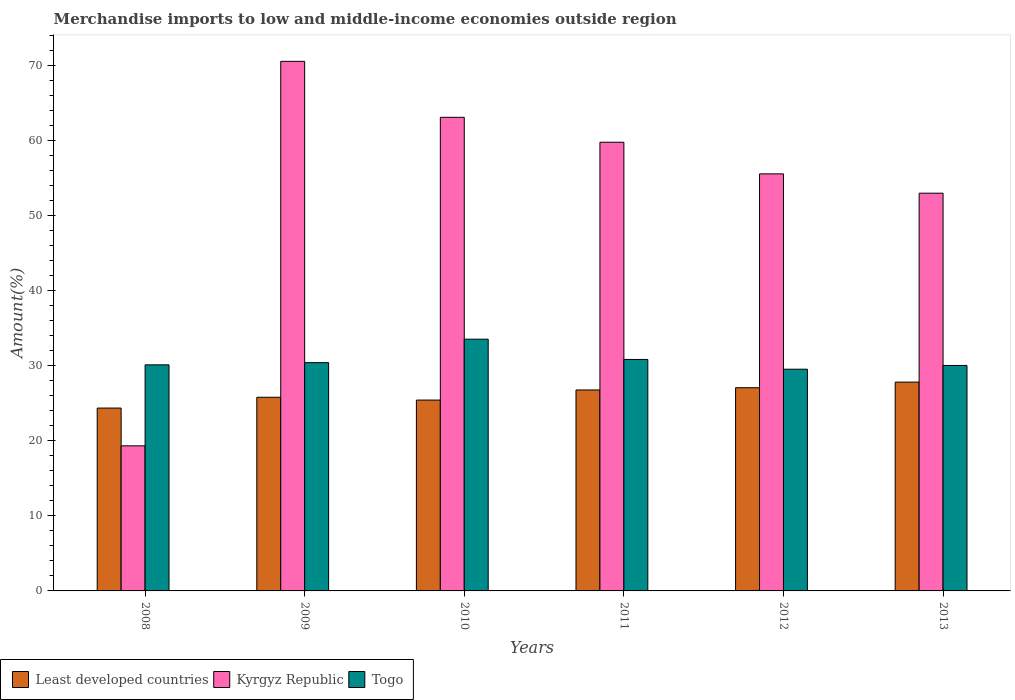How many different coloured bars are there?
Provide a succinct answer. 3. How many bars are there on the 5th tick from the right?
Your response must be concise. 3. What is the label of the 2nd group of bars from the left?
Ensure brevity in your answer.  2009. What is the percentage of amount earned from merchandise imports in Togo in 2013?
Make the answer very short. 30.05. Across all years, what is the maximum percentage of amount earned from merchandise imports in Kyrgyz Republic?
Give a very brief answer. 70.57. Across all years, what is the minimum percentage of amount earned from merchandise imports in Togo?
Your response must be concise. 29.55. In which year was the percentage of amount earned from merchandise imports in Kyrgyz Republic maximum?
Make the answer very short. 2009. What is the total percentage of amount earned from merchandise imports in Kyrgyz Republic in the graph?
Offer a very short reply. 321.39. What is the difference between the percentage of amount earned from merchandise imports in Least developed countries in 2009 and that in 2010?
Ensure brevity in your answer.  0.38. What is the difference between the percentage of amount earned from merchandise imports in Togo in 2011 and the percentage of amount earned from merchandise imports in Least developed countries in 2008?
Your answer should be very brief. 6.48. What is the average percentage of amount earned from merchandise imports in Kyrgyz Republic per year?
Your answer should be compact. 53.57. In the year 2013, what is the difference between the percentage of amount earned from merchandise imports in Kyrgyz Republic and percentage of amount earned from merchandise imports in Least developed countries?
Give a very brief answer. 25.18. In how many years, is the percentage of amount earned from merchandise imports in Togo greater than 46 %?
Your response must be concise. 0. What is the ratio of the percentage of amount earned from merchandise imports in Kyrgyz Republic in 2010 to that in 2012?
Your answer should be very brief. 1.14. Is the percentage of amount earned from merchandise imports in Least developed countries in 2009 less than that in 2013?
Keep it short and to the point. Yes. Is the difference between the percentage of amount earned from merchandise imports in Kyrgyz Republic in 2008 and 2011 greater than the difference between the percentage of amount earned from merchandise imports in Least developed countries in 2008 and 2011?
Your response must be concise. No. What is the difference between the highest and the second highest percentage of amount earned from merchandise imports in Least developed countries?
Ensure brevity in your answer.  0.75. What is the difference between the highest and the lowest percentage of amount earned from merchandise imports in Least developed countries?
Ensure brevity in your answer.  3.46. What does the 2nd bar from the left in 2010 represents?
Ensure brevity in your answer.  Kyrgyz Republic. What does the 3rd bar from the right in 2013 represents?
Give a very brief answer. Least developed countries. How many bars are there?
Provide a succinct answer. 18. Does the graph contain grids?
Offer a very short reply. No. What is the title of the graph?
Your answer should be compact. Merchandise imports to low and middle-income economies outside region. Does "San Marino" appear as one of the legend labels in the graph?
Provide a succinct answer. No. What is the label or title of the Y-axis?
Provide a succinct answer. Amount(%). What is the Amount(%) of Least developed countries in 2008?
Make the answer very short. 24.37. What is the Amount(%) in Kyrgyz Republic in 2008?
Ensure brevity in your answer.  19.33. What is the Amount(%) of Togo in 2008?
Offer a terse response. 30.13. What is the Amount(%) in Least developed countries in 2009?
Provide a short and direct response. 25.81. What is the Amount(%) in Kyrgyz Republic in 2009?
Keep it short and to the point. 70.57. What is the Amount(%) in Togo in 2009?
Your answer should be very brief. 30.42. What is the Amount(%) of Least developed countries in 2010?
Ensure brevity in your answer.  25.43. What is the Amount(%) in Kyrgyz Republic in 2010?
Provide a succinct answer. 63.11. What is the Amount(%) of Togo in 2010?
Your answer should be very brief. 33.55. What is the Amount(%) of Least developed countries in 2011?
Give a very brief answer. 26.78. What is the Amount(%) of Kyrgyz Republic in 2011?
Provide a succinct answer. 59.79. What is the Amount(%) in Togo in 2011?
Your answer should be compact. 30.85. What is the Amount(%) in Least developed countries in 2012?
Provide a short and direct response. 27.08. What is the Amount(%) in Kyrgyz Republic in 2012?
Keep it short and to the point. 55.58. What is the Amount(%) of Togo in 2012?
Your response must be concise. 29.55. What is the Amount(%) in Least developed countries in 2013?
Your answer should be very brief. 27.83. What is the Amount(%) in Kyrgyz Republic in 2013?
Your answer should be very brief. 53. What is the Amount(%) of Togo in 2013?
Offer a terse response. 30.05. Across all years, what is the maximum Amount(%) of Least developed countries?
Provide a short and direct response. 27.83. Across all years, what is the maximum Amount(%) in Kyrgyz Republic?
Provide a short and direct response. 70.57. Across all years, what is the maximum Amount(%) in Togo?
Your answer should be compact. 33.55. Across all years, what is the minimum Amount(%) of Least developed countries?
Offer a terse response. 24.37. Across all years, what is the minimum Amount(%) of Kyrgyz Republic?
Your answer should be very brief. 19.33. Across all years, what is the minimum Amount(%) in Togo?
Give a very brief answer. 29.55. What is the total Amount(%) of Least developed countries in the graph?
Provide a succinct answer. 157.29. What is the total Amount(%) in Kyrgyz Republic in the graph?
Your response must be concise. 321.39. What is the total Amount(%) in Togo in the graph?
Make the answer very short. 184.53. What is the difference between the Amount(%) of Least developed countries in 2008 and that in 2009?
Offer a very short reply. -1.44. What is the difference between the Amount(%) of Kyrgyz Republic in 2008 and that in 2009?
Offer a terse response. -51.24. What is the difference between the Amount(%) in Togo in 2008 and that in 2009?
Offer a terse response. -0.3. What is the difference between the Amount(%) of Least developed countries in 2008 and that in 2010?
Offer a terse response. -1.07. What is the difference between the Amount(%) of Kyrgyz Republic in 2008 and that in 2010?
Offer a terse response. -43.78. What is the difference between the Amount(%) in Togo in 2008 and that in 2010?
Your response must be concise. -3.42. What is the difference between the Amount(%) of Least developed countries in 2008 and that in 2011?
Provide a succinct answer. -2.41. What is the difference between the Amount(%) of Kyrgyz Republic in 2008 and that in 2011?
Provide a short and direct response. -40.46. What is the difference between the Amount(%) in Togo in 2008 and that in 2011?
Your answer should be very brief. -0.72. What is the difference between the Amount(%) in Least developed countries in 2008 and that in 2012?
Your response must be concise. -2.71. What is the difference between the Amount(%) in Kyrgyz Republic in 2008 and that in 2012?
Your response must be concise. -36.24. What is the difference between the Amount(%) of Togo in 2008 and that in 2012?
Keep it short and to the point. 0.58. What is the difference between the Amount(%) of Least developed countries in 2008 and that in 2013?
Make the answer very short. -3.46. What is the difference between the Amount(%) in Kyrgyz Republic in 2008 and that in 2013?
Give a very brief answer. -33.67. What is the difference between the Amount(%) of Togo in 2008 and that in 2013?
Ensure brevity in your answer.  0.08. What is the difference between the Amount(%) of Least developed countries in 2009 and that in 2010?
Offer a very short reply. 0.38. What is the difference between the Amount(%) in Kyrgyz Republic in 2009 and that in 2010?
Offer a terse response. 7.46. What is the difference between the Amount(%) in Togo in 2009 and that in 2010?
Offer a very short reply. -3.13. What is the difference between the Amount(%) of Least developed countries in 2009 and that in 2011?
Make the answer very short. -0.97. What is the difference between the Amount(%) in Kyrgyz Republic in 2009 and that in 2011?
Give a very brief answer. 10.78. What is the difference between the Amount(%) in Togo in 2009 and that in 2011?
Keep it short and to the point. -0.42. What is the difference between the Amount(%) in Least developed countries in 2009 and that in 2012?
Give a very brief answer. -1.27. What is the difference between the Amount(%) in Kyrgyz Republic in 2009 and that in 2012?
Offer a terse response. 14.99. What is the difference between the Amount(%) in Togo in 2009 and that in 2012?
Give a very brief answer. 0.88. What is the difference between the Amount(%) of Least developed countries in 2009 and that in 2013?
Give a very brief answer. -2.02. What is the difference between the Amount(%) of Kyrgyz Republic in 2009 and that in 2013?
Your response must be concise. 17.57. What is the difference between the Amount(%) in Togo in 2009 and that in 2013?
Your answer should be very brief. 0.37. What is the difference between the Amount(%) of Least developed countries in 2010 and that in 2011?
Make the answer very short. -1.35. What is the difference between the Amount(%) of Kyrgyz Republic in 2010 and that in 2011?
Your answer should be compact. 3.32. What is the difference between the Amount(%) of Togo in 2010 and that in 2011?
Make the answer very short. 2.7. What is the difference between the Amount(%) in Least developed countries in 2010 and that in 2012?
Make the answer very short. -1.65. What is the difference between the Amount(%) in Kyrgyz Republic in 2010 and that in 2012?
Provide a short and direct response. 7.54. What is the difference between the Amount(%) of Togo in 2010 and that in 2012?
Your answer should be very brief. 4. What is the difference between the Amount(%) in Least developed countries in 2010 and that in 2013?
Make the answer very short. -2.39. What is the difference between the Amount(%) in Kyrgyz Republic in 2010 and that in 2013?
Provide a succinct answer. 10.11. What is the difference between the Amount(%) of Togo in 2010 and that in 2013?
Offer a terse response. 3.5. What is the difference between the Amount(%) in Least developed countries in 2011 and that in 2012?
Your answer should be compact. -0.3. What is the difference between the Amount(%) of Kyrgyz Republic in 2011 and that in 2012?
Ensure brevity in your answer.  4.21. What is the difference between the Amount(%) in Least developed countries in 2011 and that in 2013?
Your answer should be very brief. -1.05. What is the difference between the Amount(%) in Kyrgyz Republic in 2011 and that in 2013?
Provide a short and direct response. 6.79. What is the difference between the Amount(%) of Togo in 2011 and that in 2013?
Provide a short and direct response. 0.8. What is the difference between the Amount(%) of Least developed countries in 2012 and that in 2013?
Provide a succinct answer. -0.75. What is the difference between the Amount(%) of Kyrgyz Republic in 2012 and that in 2013?
Offer a terse response. 2.58. What is the difference between the Amount(%) in Togo in 2012 and that in 2013?
Ensure brevity in your answer.  -0.5. What is the difference between the Amount(%) of Least developed countries in 2008 and the Amount(%) of Kyrgyz Republic in 2009?
Offer a terse response. -46.2. What is the difference between the Amount(%) of Least developed countries in 2008 and the Amount(%) of Togo in 2009?
Offer a very short reply. -6.05. What is the difference between the Amount(%) of Kyrgyz Republic in 2008 and the Amount(%) of Togo in 2009?
Give a very brief answer. -11.09. What is the difference between the Amount(%) of Least developed countries in 2008 and the Amount(%) of Kyrgyz Republic in 2010?
Give a very brief answer. -38.75. What is the difference between the Amount(%) of Least developed countries in 2008 and the Amount(%) of Togo in 2010?
Your answer should be compact. -9.18. What is the difference between the Amount(%) of Kyrgyz Republic in 2008 and the Amount(%) of Togo in 2010?
Your answer should be very brief. -14.21. What is the difference between the Amount(%) in Least developed countries in 2008 and the Amount(%) in Kyrgyz Republic in 2011?
Offer a very short reply. -35.43. What is the difference between the Amount(%) in Least developed countries in 2008 and the Amount(%) in Togo in 2011?
Make the answer very short. -6.48. What is the difference between the Amount(%) of Kyrgyz Republic in 2008 and the Amount(%) of Togo in 2011?
Keep it short and to the point. -11.51. What is the difference between the Amount(%) of Least developed countries in 2008 and the Amount(%) of Kyrgyz Republic in 2012?
Give a very brief answer. -31.21. What is the difference between the Amount(%) in Least developed countries in 2008 and the Amount(%) in Togo in 2012?
Your answer should be compact. -5.18. What is the difference between the Amount(%) of Kyrgyz Republic in 2008 and the Amount(%) of Togo in 2012?
Provide a succinct answer. -10.21. What is the difference between the Amount(%) in Least developed countries in 2008 and the Amount(%) in Kyrgyz Republic in 2013?
Make the answer very short. -28.64. What is the difference between the Amount(%) in Least developed countries in 2008 and the Amount(%) in Togo in 2013?
Provide a succinct answer. -5.68. What is the difference between the Amount(%) of Kyrgyz Republic in 2008 and the Amount(%) of Togo in 2013?
Your answer should be very brief. -10.71. What is the difference between the Amount(%) in Least developed countries in 2009 and the Amount(%) in Kyrgyz Republic in 2010?
Give a very brief answer. -37.31. What is the difference between the Amount(%) in Least developed countries in 2009 and the Amount(%) in Togo in 2010?
Keep it short and to the point. -7.74. What is the difference between the Amount(%) of Kyrgyz Republic in 2009 and the Amount(%) of Togo in 2010?
Ensure brevity in your answer.  37.02. What is the difference between the Amount(%) in Least developed countries in 2009 and the Amount(%) in Kyrgyz Republic in 2011?
Give a very brief answer. -33.98. What is the difference between the Amount(%) of Least developed countries in 2009 and the Amount(%) of Togo in 2011?
Keep it short and to the point. -5.04. What is the difference between the Amount(%) in Kyrgyz Republic in 2009 and the Amount(%) in Togo in 2011?
Keep it short and to the point. 39.73. What is the difference between the Amount(%) of Least developed countries in 2009 and the Amount(%) of Kyrgyz Republic in 2012?
Ensure brevity in your answer.  -29.77. What is the difference between the Amount(%) of Least developed countries in 2009 and the Amount(%) of Togo in 2012?
Make the answer very short. -3.74. What is the difference between the Amount(%) of Kyrgyz Republic in 2009 and the Amount(%) of Togo in 2012?
Offer a very short reply. 41.03. What is the difference between the Amount(%) of Least developed countries in 2009 and the Amount(%) of Kyrgyz Republic in 2013?
Provide a short and direct response. -27.2. What is the difference between the Amount(%) in Least developed countries in 2009 and the Amount(%) in Togo in 2013?
Provide a succinct answer. -4.24. What is the difference between the Amount(%) of Kyrgyz Republic in 2009 and the Amount(%) of Togo in 2013?
Your answer should be compact. 40.52. What is the difference between the Amount(%) in Least developed countries in 2010 and the Amount(%) in Kyrgyz Republic in 2011?
Provide a short and direct response. -34.36. What is the difference between the Amount(%) in Least developed countries in 2010 and the Amount(%) in Togo in 2011?
Give a very brief answer. -5.41. What is the difference between the Amount(%) of Kyrgyz Republic in 2010 and the Amount(%) of Togo in 2011?
Make the answer very short. 32.27. What is the difference between the Amount(%) of Least developed countries in 2010 and the Amount(%) of Kyrgyz Republic in 2012?
Your answer should be compact. -30.15. What is the difference between the Amount(%) in Least developed countries in 2010 and the Amount(%) in Togo in 2012?
Your answer should be compact. -4.11. What is the difference between the Amount(%) in Kyrgyz Republic in 2010 and the Amount(%) in Togo in 2012?
Your answer should be very brief. 33.57. What is the difference between the Amount(%) of Least developed countries in 2010 and the Amount(%) of Kyrgyz Republic in 2013?
Provide a short and direct response. -27.57. What is the difference between the Amount(%) of Least developed countries in 2010 and the Amount(%) of Togo in 2013?
Give a very brief answer. -4.62. What is the difference between the Amount(%) in Kyrgyz Republic in 2010 and the Amount(%) in Togo in 2013?
Offer a very short reply. 33.07. What is the difference between the Amount(%) in Least developed countries in 2011 and the Amount(%) in Kyrgyz Republic in 2012?
Ensure brevity in your answer.  -28.8. What is the difference between the Amount(%) in Least developed countries in 2011 and the Amount(%) in Togo in 2012?
Provide a succinct answer. -2.77. What is the difference between the Amount(%) of Kyrgyz Republic in 2011 and the Amount(%) of Togo in 2012?
Make the answer very short. 30.25. What is the difference between the Amount(%) of Least developed countries in 2011 and the Amount(%) of Kyrgyz Republic in 2013?
Give a very brief answer. -26.22. What is the difference between the Amount(%) in Least developed countries in 2011 and the Amount(%) in Togo in 2013?
Your response must be concise. -3.27. What is the difference between the Amount(%) of Kyrgyz Republic in 2011 and the Amount(%) of Togo in 2013?
Ensure brevity in your answer.  29.75. What is the difference between the Amount(%) in Least developed countries in 2012 and the Amount(%) in Kyrgyz Republic in 2013?
Provide a short and direct response. -25.92. What is the difference between the Amount(%) in Least developed countries in 2012 and the Amount(%) in Togo in 2013?
Make the answer very short. -2.97. What is the difference between the Amount(%) in Kyrgyz Republic in 2012 and the Amount(%) in Togo in 2013?
Make the answer very short. 25.53. What is the average Amount(%) of Least developed countries per year?
Your answer should be very brief. 26.22. What is the average Amount(%) in Kyrgyz Republic per year?
Ensure brevity in your answer.  53.57. What is the average Amount(%) in Togo per year?
Give a very brief answer. 30.76. In the year 2008, what is the difference between the Amount(%) of Least developed countries and Amount(%) of Kyrgyz Republic?
Offer a terse response. 5.03. In the year 2008, what is the difference between the Amount(%) of Least developed countries and Amount(%) of Togo?
Offer a terse response. -5.76. In the year 2008, what is the difference between the Amount(%) in Kyrgyz Republic and Amount(%) in Togo?
Offer a very short reply. -10.79. In the year 2009, what is the difference between the Amount(%) of Least developed countries and Amount(%) of Kyrgyz Republic?
Provide a succinct answer. -44.76. In the year 2009, what is the difference between the Amount(%) in Least developed countries and Amount(%) in Togo?
Your answer should be very brief. -4.61. In the year 2009, what is the difference between the Amount(%) of Kyrgyz Republic and Amount(%) of Togo?
Provide a short and direct response. 40.15. In the year 2010, what is the difference between the Amount(%) in Least developed countries and Amount(%) in Kyrgyz Republic?
Your response must be concise. -37.68. In the year 2010, what is the difference between the Amount(%) in Least developed countries and Amount(%) in Togo?
Your answer should be compact. -8.12. In the year 2010, what is the difference between the Amount(%) of Kyrgyz Republic and Amount(%) of Togo?
Offer a terse response. 29.56. In the year 2011, what is the difference between the Amount(%) of Least developed countries and Amount(%) of Kyrgyz Republic?
Offer a terse response. -33.01. In the year 2011, what is the difference between the Amount(%) in Least developed countries and Amount(%) in Togo?
Make the answer very short. -4.07. In the year 2011, what is the difference between the Amount(%) in Kyrgyz Republic and Amount(%) in Togo?
Your answer should be compact. 28.95. In the year 2012, what is the difference between the Amount(%) of Least developed countries and Amount(%) of Kyrgyz Republic?
Make the answer very short. -28.5. In the year 2012, what is the difference between the Amount(%) in Least developed countries and Amount(%) in Togo?
Provide a succinct answer. -2.47. In the year 2012, what is the difference between the Amount(%) in Kyrgyz Republic and Amount(%) in Togo?
Your answer should be compact. 26.03. In the year 2013, what is the difference between the Amount(%) in Least developed countries and Amount(%) in Kyrgyz Republic?
Keep it short and to the point. -25.18. In the year 2013, what is the difference between the Amount(%) in Least developed countries and Amount(%) in Togo?
Offer a terse response. -2.22. In the year 2013, what is the difference between the Amount(%) of Kyrgyz Republic and Amount(%) of Togo?
Make the answer very short. 22.96. What is the ratio of the Amount(%) of Least developed countries in 2008 to that in 2009?
Provide a short and direct response. 0.94. What is the ratio of the Amount(%) of Kyrgyz Republic in 2008 to that in 2009?
Provide a short and direct response. 0.27. What is the ratio of the Amount(%) in Togo in 2008 to that in 2009?
Ensure brevity in your answer.  0.99. What is the ratio of the Amount(%) in Least developed countries in 2008 to that in 2010?
Offer a terse response. 0.96. What is the ratio of the Amount(%) of Kyrgyz Republic in 2008 to that in 2010?
Keep it short and to the point. 0.31. What is the ratio of the Amount(%) in Togo in 2008 to that in 2010?
Keep it short and to the point. 0.9. What is the ratio of the Amount(%) in Least developed countries in 2008 to that in 2011?
Make the answer very short. 0.91. What is the ratio of the Amount(%) of Kyrgyz Republic in 2008 to that in 2011?
Provide a short and direct response. 0.32. What is the ratio of the Amount(%) of Togo in 2008 to that in 2011?
Keep it short and to the point. 0.98. What is the ratio of the Amount(%) of Least developed countries in 2008 to that in 2012?
Provide a short and direct response. 0.9. What is the ratio of the Amount(%) in Kyrgyz Republic in 2008 to that in 2012?
Your answer should be compact. 0.35. What is the ratio of the Amount(%) of Togo in 2008 to that in 2012?
Your answer should be compact. 1.02. What is the ratio of the Amount(%) in Least developed countries in 2008 to that in 2013?
Your answer should be compact. 0.88. What is the ratio of the Amount(%) of Kyrgyz Republic in 2008 to that in 2013?
Provide a short and direct response. 0.36. What is the ratio of the Amount(%) of Togo in 2008 to that in 2013?
Give a very brief answer. 1. What is the ratio of the Amount(%) in Least developed countries in 2009 to that in 2010?
Keep it short and to the point. 1.01. What is the ratio of the Amount(%) in Kyrgyz Republic in 2009 to that in 2010?
Give a very brief answer. 1.12. What is the ratio of the Amount(%) of Togo in 2009 to that in 2010?
Your answer should be compact. 0.91. What is the ratio of the Amount(%) in Least developed countries in 2009 to that in 2011?
Offer a terse response. 0.96. What is the ratio of the Amount(%) of Kyrgyz Republic in 2009 to that in 2011?
Your answer should be compact. 1.18. What is the ratio of the Amount(%) of Togo in 2009 to that in 2011?
Offer a terse response. 0.99. What is the ratio of the Amount(%) of Least developed countries in 2009 to that in 2012?
Offer a terse response. 0.95. What is the ratio of the Amount(%) in Kyrgyz Republic in 2009 to that in 2012?
Give a very brief answer. 1.27. What is the ratio of the Amount(%) in Togo in 2009 to that in 2012?
Give a very brief answer. 1.03. What is the ratio of the Amount(%) in Least developed countries in 2009 to that in 2013?
Give a very brief answer. 0.93. What is the ratio of the Amount(%) in Kyrgyz Republic in 2009 to that in 2013?
Provide a succinct answer. 1.33. What is the ratio of the Amount(%) in Togo in 2009 to that in 2013?
Provide a short and direct response. 1.01. What is the ratio of the Amount(%) in Least developed countries in 2010 to that in 2011?
Give a very brief answer. 0.95. What is the ratio of the Amount(%) of Kyrgyz Republic in 2010 to that in 2011?
Offer a very short reply. 1.06. What is the ratio of the Amount(%) of Togo in 2010 to that in 2011?
Provide a succinct answer. 1.09. What is the ratio of the Amount(%) of Least developed countries in 2010 to that in 2012?
Keep it short and to the point. 0.94. What is the ratio of the Amount(%) in Kyrgyz Republic in 2010 to that in 2012?
Your answer should be very brief. 1.14. What is the ratio of the Amount(%) in Togo in 2010 to that in 2012?
Your answer should be compact. 1.14. What is the ratio of the Amount(%) in Least developed countries in 2010 to that in 2013?
Your response must be concise. 0.91. What is the ratio of the Amount(%) in Kyrgyz Republic in 2010 to that in 2013?
Give a very brief answer. 1.19. What is the ratio of the Amount(%) in Togo in 2010 to that in 2013?
Give a very brief answer. 1.12. What is the ratio of the Amount(%) of Kyrgyz Republic in 2011 to that in 2012?
Keep it short and to the point. 1.08. What is the ratio of the Amount(%) in Togo in 2011 to that in 2012?
Provide a short and direct response. 1.04. What is the ratio of the Amount(%) of Least developed countries in 2011 to that in 2013?
Give a very brief answer. 0.96. What is the ratio of the Amount(%) in Kyrgyz Republic in 2011 to that in 2013?
Ensure brevity in your answer.  1.13. What is the ratio of the Amount(%) in Togo in 2011 to that in 2013?
Provide a short and direct response. 1.03. What is the ratio of the Amount(%) of Least developed countries in 2012 to that in 2013?
Give a very brief answer. 0.97. What is the ratio of the Amount(%) of Kyrgyz Republic in 2012 to that in 2013?
Your answer should be very brief. 1.05. What is the ratio of the Amount(%) in Togo in 2012 to that in 2013?
Offer a very short reply. 0.98. What is the difference between the highest and the second highest Amount(%) in Least developed countries?
Provide a short and direct response. 0.75. What is the difference between the highest and the second highest Amount(%) in Kyrgyz Republic?
Offer a terse response. 7.46. What is the difference between the highest and the second highest Amount(%) of Togo?
Your response must be concise. 2.7. What is the difference between the highest and the lowest Amount(%) in Least developed countries?
Give a very brief answer. 3.46. What is the difference between the highest and the lowest Amount(%) of Kyrgyz Republic?
Your answer should be compact. 51.24. What is the difference between the highest and the lowest Amount(%) of Togo?
Ensure brevity in your answer.  4. 